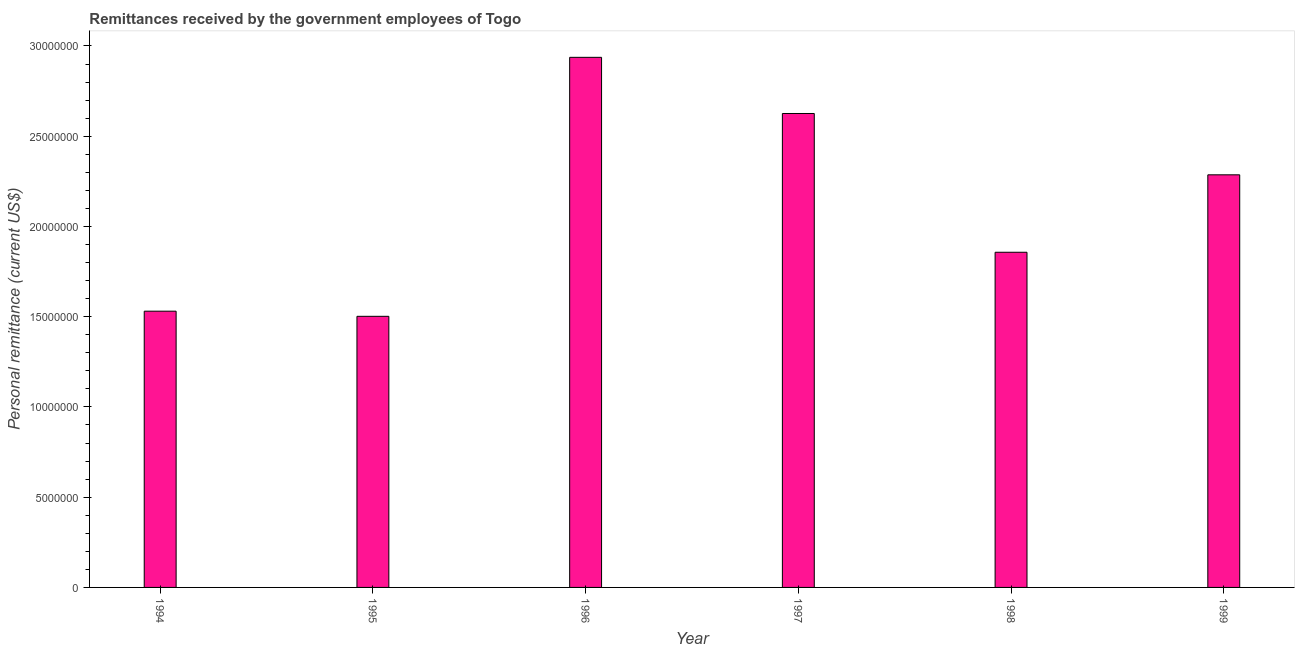Does the graph contain any zero values?
Provide a succinct answer. No. What is the title of the graph?
Provide a short and direct response. Remittances received by the government employees of Togo. What is the label or title of the Y-axis?
Your answer should be very brief. Personal remittance (current US$). What is the personal remittances in 1998?
Provide a succinct answer. 1.86e+07. Across all years, what is the maximum personal remittances?
Make the answer very short. 2.94e+07. Across all years, what is the minimum personal remittances?
Your answer should be compact. 1.50e+07. In which year was the personal remittances maximum?
Provide a succinct answer. 1996. What is the sum of the personal remittances?
Your answer should be very brief. 1.27e+08. What is the difference between the personal remittances in 1996 and 1997?
Provide a short and direct response. 3.11e+06. What is the average personal remittances per year?
Offer a terse response. 2.12e+07. What is the median personal remittances?
Your answer should be very brief. 2.07e+07. What is the ratio of the personal remittances in 1995 to that in 1997?
Provide a short and direct response. 0.57. Is the personal remittances in 1996 less than that in 1998?
Provide a succinct answer. No. Is the difference between the personal remittances in 1995 and 1999 greater than the difference between any two years?
Give a very brief answer. No. What is the difference between the highest and the second highest personal remittances?
Your response must be concise. 3.11e+06. Is the sum of the personal remittances in 1996 and 1997 greater than the maximum personal remittances across all years?
Provide a short and direct response. Yes. What is the difference between the highest and the lowest personal remittances?
Your answer should be compact. 1.43e+07. How many bars are there?
Make the answer very short. 6. Are the values on the major ticks of Y-axis written in scientific E-notation?
Provide a succinct answer. No. What is the Personal remittance (current US$) of 1994?
Your answer should be very brief. 1.53e+07. What is the Personal remittance (current US$) in 1995?
Your answer should be compact. 1.50e+07. What is the Personal remittance (current US$) of 1996?
Ensure brevity in your answer.  2.94e+07. What is the Personal remittance (current US$) of 1997?
Give a very brief answer. 2.63e+07. What is the Personal remittance (current US$) in 1998?
Your response must be concise. 1.86e+07. What is the Personal remittance (current US$) of 1999?
Give a very brief answer. 2.29e+07. What is the difference between the Personal remittance (current US$) in 1994 and 1995?
Keep it short and to the point. 2.84e+05. What is the difference between the Personal remittance (current US$) in 1994 and 1996?
Make the answer very short. -1.41e+07. What is the difference between the Personal remittance (current US$) in 1994 and 1997?
Your response must be concise. -1.10e+07. What is the difference between the Personal remittance (current US$) in 1994 and 1998?
Your answer should be compact. -3.26e+06. What is the difference between the Personal remittance (current US$) in 1994 and 1999?
Keep it short and to the point. -7.56e+06. What is the difference between the Personal remittance (current US$) in 1995 and 1996?
Make the answer very short. -1.43e+07. What is the difference between the Personal remittance (current US$) in 1995 and 1997?
Your response must be concise. -1.12e+07. What is the difference between the Personal remittance (current US$) in 1995 and 1998?
Provide a succinct answer. -3.55e+06. What is the difference between the Personal remittance (current US$) in 1995 and 1999?
Provide a succinct answer. -7.84e+06. What is the difference between the Personal remittance (current US$) in 1996 and 1997?
Your answer should be compact. 3.11e+06. What is the difference between the Personal remittance (current US$) in 1996 and 1998?
Make the answer very short. 1.08e+07. What is the difference between the Personal remittance (current US$) in 1996 and 1999?
Make the answer very short. 6.51e+06. What is the difference between the Personal remittance (current US$) in 1997 and 1998?
Provide a succinct answer. 7.69e+06. What is the difference between the Personal remittance (current US$) in 1997 and 1999?
Make the answer very short. 3.40e+06. What is the difference between the Personal remittance (current US$) in 1998 and 1999?
Your answer should be very brief. -4.29e+06. What is the ratio of the Personal remittance (current US$) in 1994 to that in 1996?
Your response must be concise. 0.52. What is the ratio of the Personal remittance (current US$) in 1994 to that in 1997?
Offer a terse response. 0.58. What is the ratio of the Personal remittance (current US$) in 1994 to that in 1998?
Provide a succinct answer. 0.82. What is the ratio of the Personal remittance (current US$) in 1994 to that in 1999?
Provide a succinct answer. 0.67. What is the ratio of the Personal remittance (current US$) in 1995 to that in 1996?
Ensure brevity in your answer.  0.51. What is the ratio of the Personal remittance (current US$) in 1995 to that in 1997?
Your answer should be compact. 0.57. What is the ratio of the Personal remittance (current US$) in 1995 to that in 1998?
Ensure brevity in your answer.  0.81. What is the ratio of the Personal remittance (current US$) in 1995 to that in 1999?
Your answer should be very brief. 0.66. What is the ratio of the Personal remittance (current US$) in 1996 to that in 1997?
Make the answer very short. 1.12. What is the ratio of the Personal remittance (current US$) in 1996 to that in 1998?
Offer a terse response. 1.58. What is the ratio of the Personal remittance (current US$) in 1996 to that in 1999?
Make the answer very short. 1.28. What is the ratio of the Personal remittance (current US$) in 1997 to that in 1998?
Make the answer very short. 1.41. What is the ratio of the Personal remittance (current US$) in 1997 to that in 1999?
Your answer should be compact. 1.15. What is the ratio of the Personal remittance (current US$) in 1998 to that in 1999?
Your answer should be very brief. 0.81. 